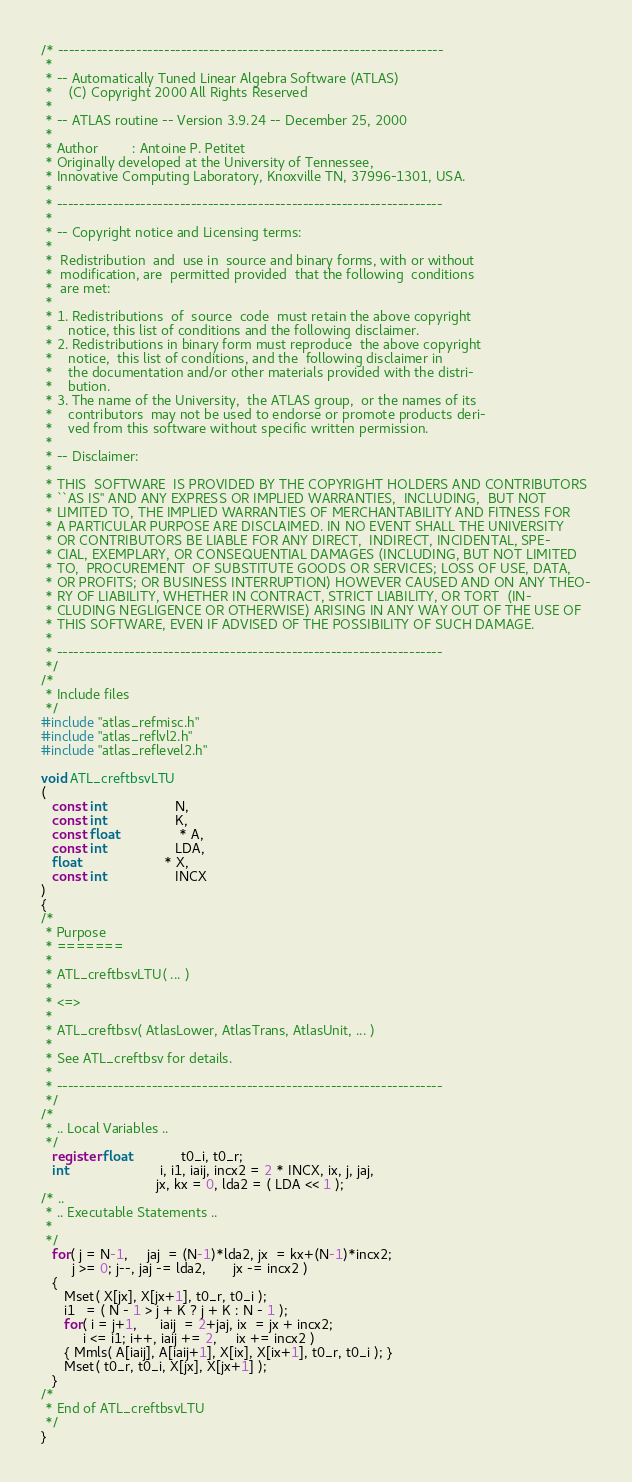<code> <loc_0><loc_0><loc_500><loc_500><_C_>/* ---------------------------------------------------------------------
 *
 * -- Automatically Tuned Linear Algebra Software (ATLAS)
 *    (C) Copyright 2000 All Rights Reserved
 *
 * -- ATLAS routine -- Version 3.9.24 -- December 25, 2000
 *
 * Author         : Antoine P. Petitet
 * Originally developed at the University of Tennessee,
 * Innovative Computing Laboratory, Knoxville TN, 37996-1301, USA.
 *
 * ---------------------------------------------------------------------
 *
 * -- Copyright notice and Licensing terms:
 *
 *  Redistribution  and  use in  source and binary forms, with or without
 *  modification, are  permitted provided  that the following  conditions
 *  are met:
 *
 * 1. Redistributions  of  source  code  must retain the above copyright
 *    notice, this list of conditions and the following disclaimer.
 * 2. Redistributions in binary form must reproduce  the above copyright
 *    notice,  this list of conditions, and the  following disclaimer in
 *    the documentation and/or other materials provided with the distri-
 *    bution.
 * 3. The name of the University,  the ATLAS group,  or the names of its
 *    contributors  may not be used to endorse or promote products deri-
 *    ved from this software without specific written permission.
 *
 * -- Disclaimer:
 *
 * THIS  SOFTWARE  IS PROVIDED BY THE COPYRIGHT HOLDERS AND CONTRIBUTORS
 * ``AS IS'' AND ANY EXPRESS OR IMPLIED WARRANTIES,  INCLUDING,  BUT NOT
 * LIMITED TO, THE IMPLIED WARRANTIES OF MERCHANTABILITY AND FITNESS FOR
 * A PARTICULAR PURPOSE ARE DISCLAIMED. IN NO EVENT SHALL THE UNIVERSITY
 * OR CONTRIBUTORS BE LIABLE FOR ANY DIRECT,  INDIRECT, INCIDENTAL, SPE-
 * CIAL, EXEMPLARY, OR CONSEQUENTIAL DAMAGES (INCLUDING, BUT NOT LIMITED
 * TO,  PROCUREMENT  OF SUBSTITUTE GOODS OR SERVICES; LOSS OF USE, DATA,
 * OR PROFITS; OR BUSINESS INTERRUPTION) HOWEVER CAUSED AND ON ANY THEO-
 * RY OF LIABILITY, WHETHER IN CONTRACT, STRICT LIABILITY, OR TORT  (IN-
 * CLUDING NEGLIGENCE OR OTHERWISE) ARISING IN ANY WAY OUT OF THE USE OF
 * THIS SOFTWARE, EVEN IF ADVISED OF THE POSSIBILITY OF SUCH DAMAGE.
 *
 * ---------------------------------------------------------------------
 */
/*
 * Include files
 */
#include "atlas_refmisc.h"
#include "atlas_reflvl2.h"
#include "atlas_reflevel2.h"

void ATL_creftbsvLTU
(
   const int                  N,
   const int                  K,
   const float                * A,
   const int                  LDA,
   float                      * X,
   const int                  INCX
)
{
/*
 * Purpose
 * =======
 *
 * ATL_creftbsvLTU( ... )
 *
 * <=>
 *
 * ATL_creftbsv( AtlasLower, AtlasTrans, AtlasUnit, ... )
 *
 * See ATL_creftbsv for details.
 *
 * ---------------------------------------------------------------------
 */
/*
 * .. Local Variables ..
 */
   register float             t0_i, t0_r;
   int                        i, i1, iaij, incx2 = 2 * INCX, ix, j, jaj,
                              jx, kx = 0, lda2 = ( LDA << 1 );
/* ..
 * .. Executable Statements ..
 *
 */
   for( j = N-1,     jaj  = (N-1)*lda2, jx  = kx+(N-1)*incx2;
        j >= 0; j--, jaj -= lda2,       jx -= incx2 )
   {
      Mset( X[jx], X[jx+1], t0_r, t0_i );
      i1   = ( N - 1 > j + K ? j + K : N - 1 );
      for( i = j+1,      iaij  = 2+jaj, ix  = jx + incx2;
           i <= i1; i++, iaij += 2,     ix += incx2 )
      { Mmls( A[iaij], A[iaij+1], X[ix], X[ix+1], t0_r, t0_i ); }
      Mset( t0_r, t0_i, X[jx], X[jx+1] );
   }
/*
 * End of ATL_creftbsvLTU
 */
}
</code> 